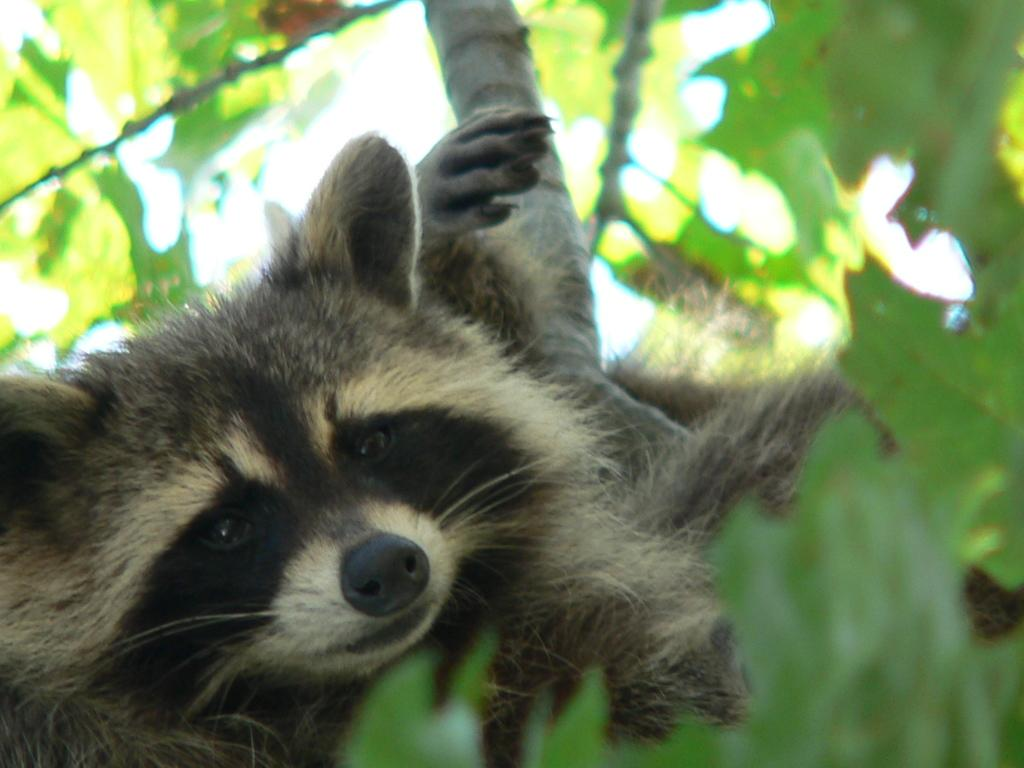What animal is present in the image? There is a raccoon in the image. Where is the raccoon located? The raccoon is on a tree. What learning system does the raccoon use to climb the tree in the image? The image does not provide information about the raccoon's learning system, and the raccoon's climbing ability is a natural instinct rather than a learned behavior. 